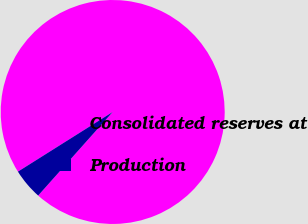Convert chart to OTSL. <chart><loc_0><loc_0><loc_500><loc_500><pie_chart><fcel>Consolidated reserves at<fcel>Production<nl><fcel>95.53%<fcel>4.47%<nl></chart> 